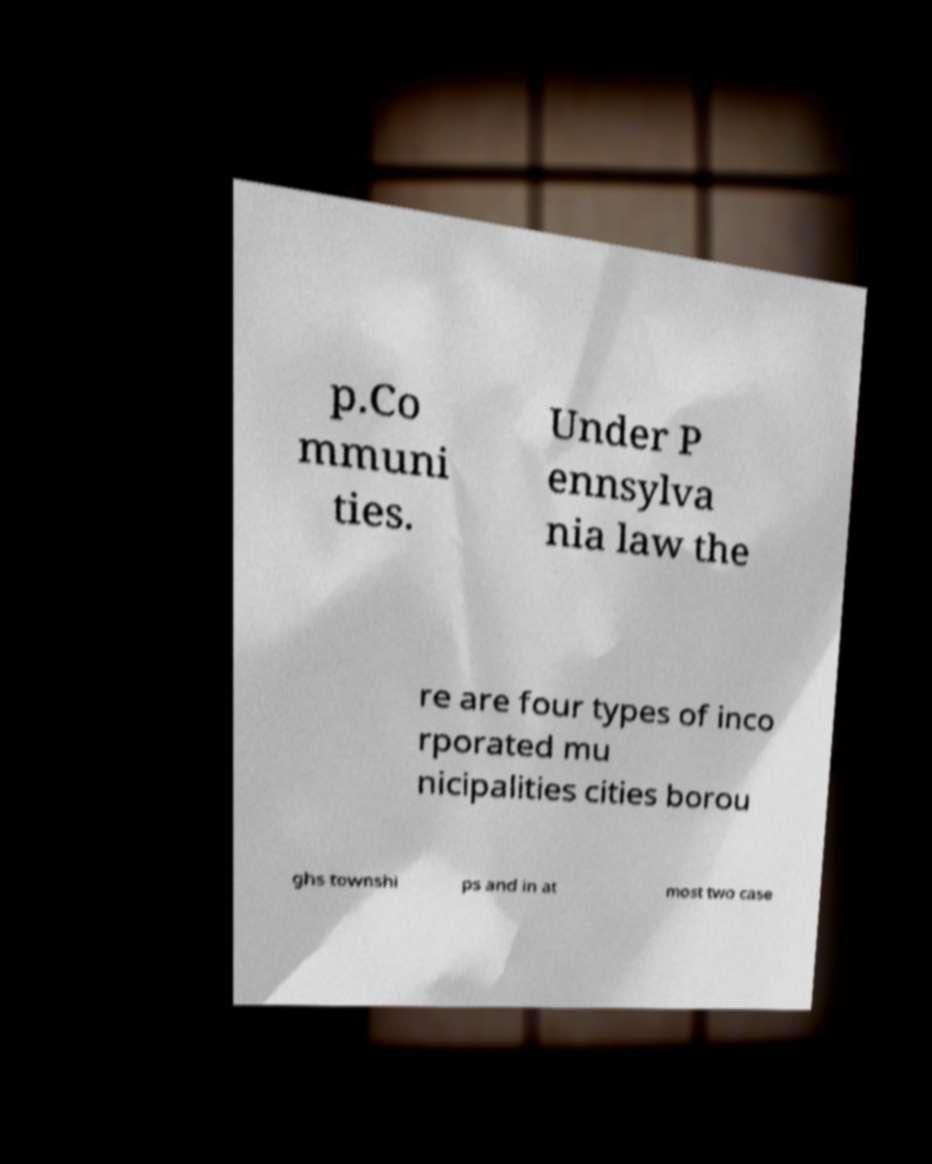What messages or text are displayed in this image? I need them in a readable, typed format. p.Co mmuni ties. Under P ennsylva nia law the re are four types of inco rporated mu nicipalities cities borou ghs townshi ps and in at most two case 